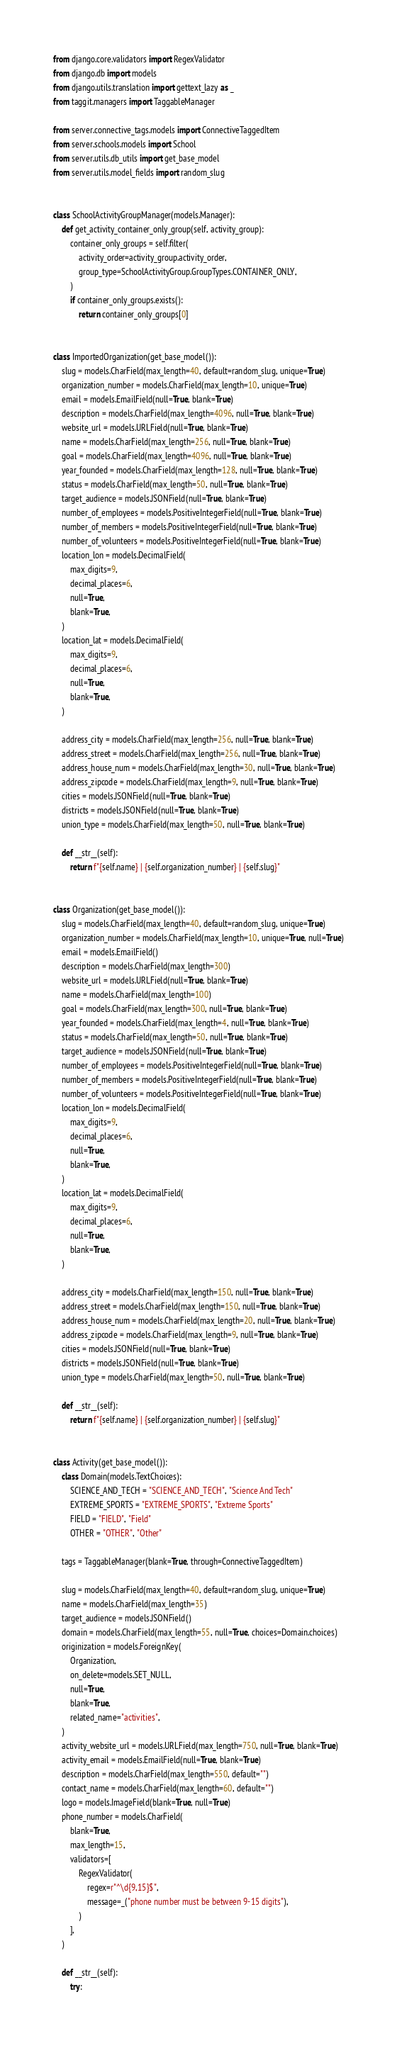Convert code to text. <code><loc_0><loc_0><loc_500><loc_500><_Python_>from django.core.validators import RegexValidator
from django.db import models
from django.utils.translation import gettext_lazy as _
from taggit.managers import TaggableManager

from server.connective_tags.models import ConnectiveTaggedItem
from server.schools.models import School
from server.utils.db_utils import get_base_model
from server.utils.model_fields import random_slug


class SchoolActivityGroupManager(models.Manager):
    def get_activity_container_only_group(self, activity_group):
        container_only_groups = self.filter(
            activity_order=activity_group.activity_order,
            group_type=SchoolActivityGroup.GroupTypes.CONTAINER_ONLY,
        )
        if container_only_groups.exists():
            return container_only_groups[0]


class ImportedOrganization(get_base_model()):
    slug = models.CharField(max_length=40, default=random_slug, unique=True)
    organization_number = models.CharField(max_length=10, unique=True)
    email = models.EmailField(null=True, blank=True)
    description = models.CharField(max_length=4096, null=True, blank=True)
    website_url = models.URLField(null=True, blank=True)
    name = models.CharField(max_length=256, null=True, blank=True)
    goal = models.CharField(max_length=4096, null=True, blank=True)
    year_founded = models.CharField(max_length=128, null=True, blank=True)
    status = models.CharField(max_length=50, null=True, blank=True)
    target_audience = models.JSONField(null=True, blank=True)
    number_of_employees = models.PositiveIntegerField(null=True, blank=True)
    number_of_members = models.PositiveIntegerField(null=True, blank=True)
    number_of_volunteers = models.PositiveIntegerField(null=True, blank=True)
    location_lon = models.DecimalField(
        max_digits=9,
        decimal_places=6,
        null=True,
        blank=True,
    )
    location_lat = models.DecimalField(
        max_digits=9,
        decimal_places=6,
        null=True,
        blank=True,
    )

    address_city = models.CharField(max_length=256, null=True, blank=True)
    address_street = models.CharField(max_length=256, null=True, blank=True)
    address_house_num = models.CharField(max_length=30, null=True, blank=True)
    address_zipcode = models.CharField(max_length=9, null=True, blank=True)
    cities = models.JSONField(null=True, blank=True)
    districts = models.JSONField(null=True, blank=True)
    union_type = models.CharField(max_length=50, null=True, blank=True)

    def __str__(self):
        return f"{self.name} | {self.organization_number} | {self.slug}"


class Organization(get_base_model()):
    slug = models.CharField(max_length=40, default=random_slug, unique=True)
    organization_number = models.CharField(max_length=10, unique=True, null=True)
    email = models.EmailField()
    description = models.CharField(max_length=300)
    website_url = models.URLField(null=True, blank=True)
    name = models.CharField(max_length=100)
    goal = models.CharField(max_length=300, null=True, blank=True)
    year_founded = models.CharField(max_length=4, null=True, blank=True)
    status = models.CharField(max_length=50, null=True, blank=True)
    target_audience = models.JSONField(null=True, blank=True)
    number_of_employees = models.PositiveIntegerField(null=True, blank=True)
    number_of_members = models.PositiveIntegerField(null=True, blank=True)
    number_of_volunteers = models.PositiveIntegerField(null=True, blank=True)
    location_lon = models.DecimalField(
        max_digits=9,
        decimal_places=6,
        null=True,
        blank=True,
    )
    location_lat = models.DecimalField(
        max_digits=9,
        decimal_places=6,
        null=True,
        blank=True,
    )

    address_city = models.CharField(max_length=150, null=True, blank=True)
    address_street = models.CharField(max_length=150, null=True, blank=True)
    address_house_num = models.CharField(max_length=20, null=True, blank=True)
    address_zipcode = models.CharField(max_length=9, null=True, blank=True)
    cities = models.JSONField(null=True, blank=True)
    districts = models.JSONField(null=True, blank=True)
    union_type = models.CharField(max_length=50, null=True, blank=True)

    def __str__(self):
        return f"{self.name} | {self.organization_number} | {self.slug}"


class Activity(get_base_model()):
    class Domain(models.TextChoices):
        SCIENCE_AND_TECH = "SCIENCE_AND_TECH", "Science And Tech"
        EXTREME_SPORTS = "EXTREME_SPORTS", "Extreme Sports"
        FIELD = "FIELD", "Field"
        OTHER = "OTHER", "Other"

    tags = TaggableManager(blank=True, through=ConnectiveTaggedItem)

    slug = models.CharField(max_length=40, default=random_slug, unique=True)
    name = models.CharField(max_length=35)
    target_audience = models.JSONField()
    domain = models.CharField(max_length=55, null=True, choices=Domain.choices)
    originization = models.ForeignKey(
        Organization,
        on_delete=models.SET_NULL,
        null=True,
        blank=True,
        related_name="activities",
    )
    activity_website_url = models.URLField(max_length=750, null=True, blank=True)
    activity_email = models.EmailField(null=True, blank=True)
    description = models.CharField(max_length=550, default="")
    contact_name = models.CharField(max_length=60, default="")
    logo = models.ImageField(blank=True, null=True)
    phone_number = models.CharField(
        blank=True,
        max_length=15,
        validators=[
            RegexValidator(
                regex=r"^\d{9,15}$",
                message=_("phone number must be between 9-15 digits"),
            )
        ],
    )

    def __str__(self):
        try:</code> 